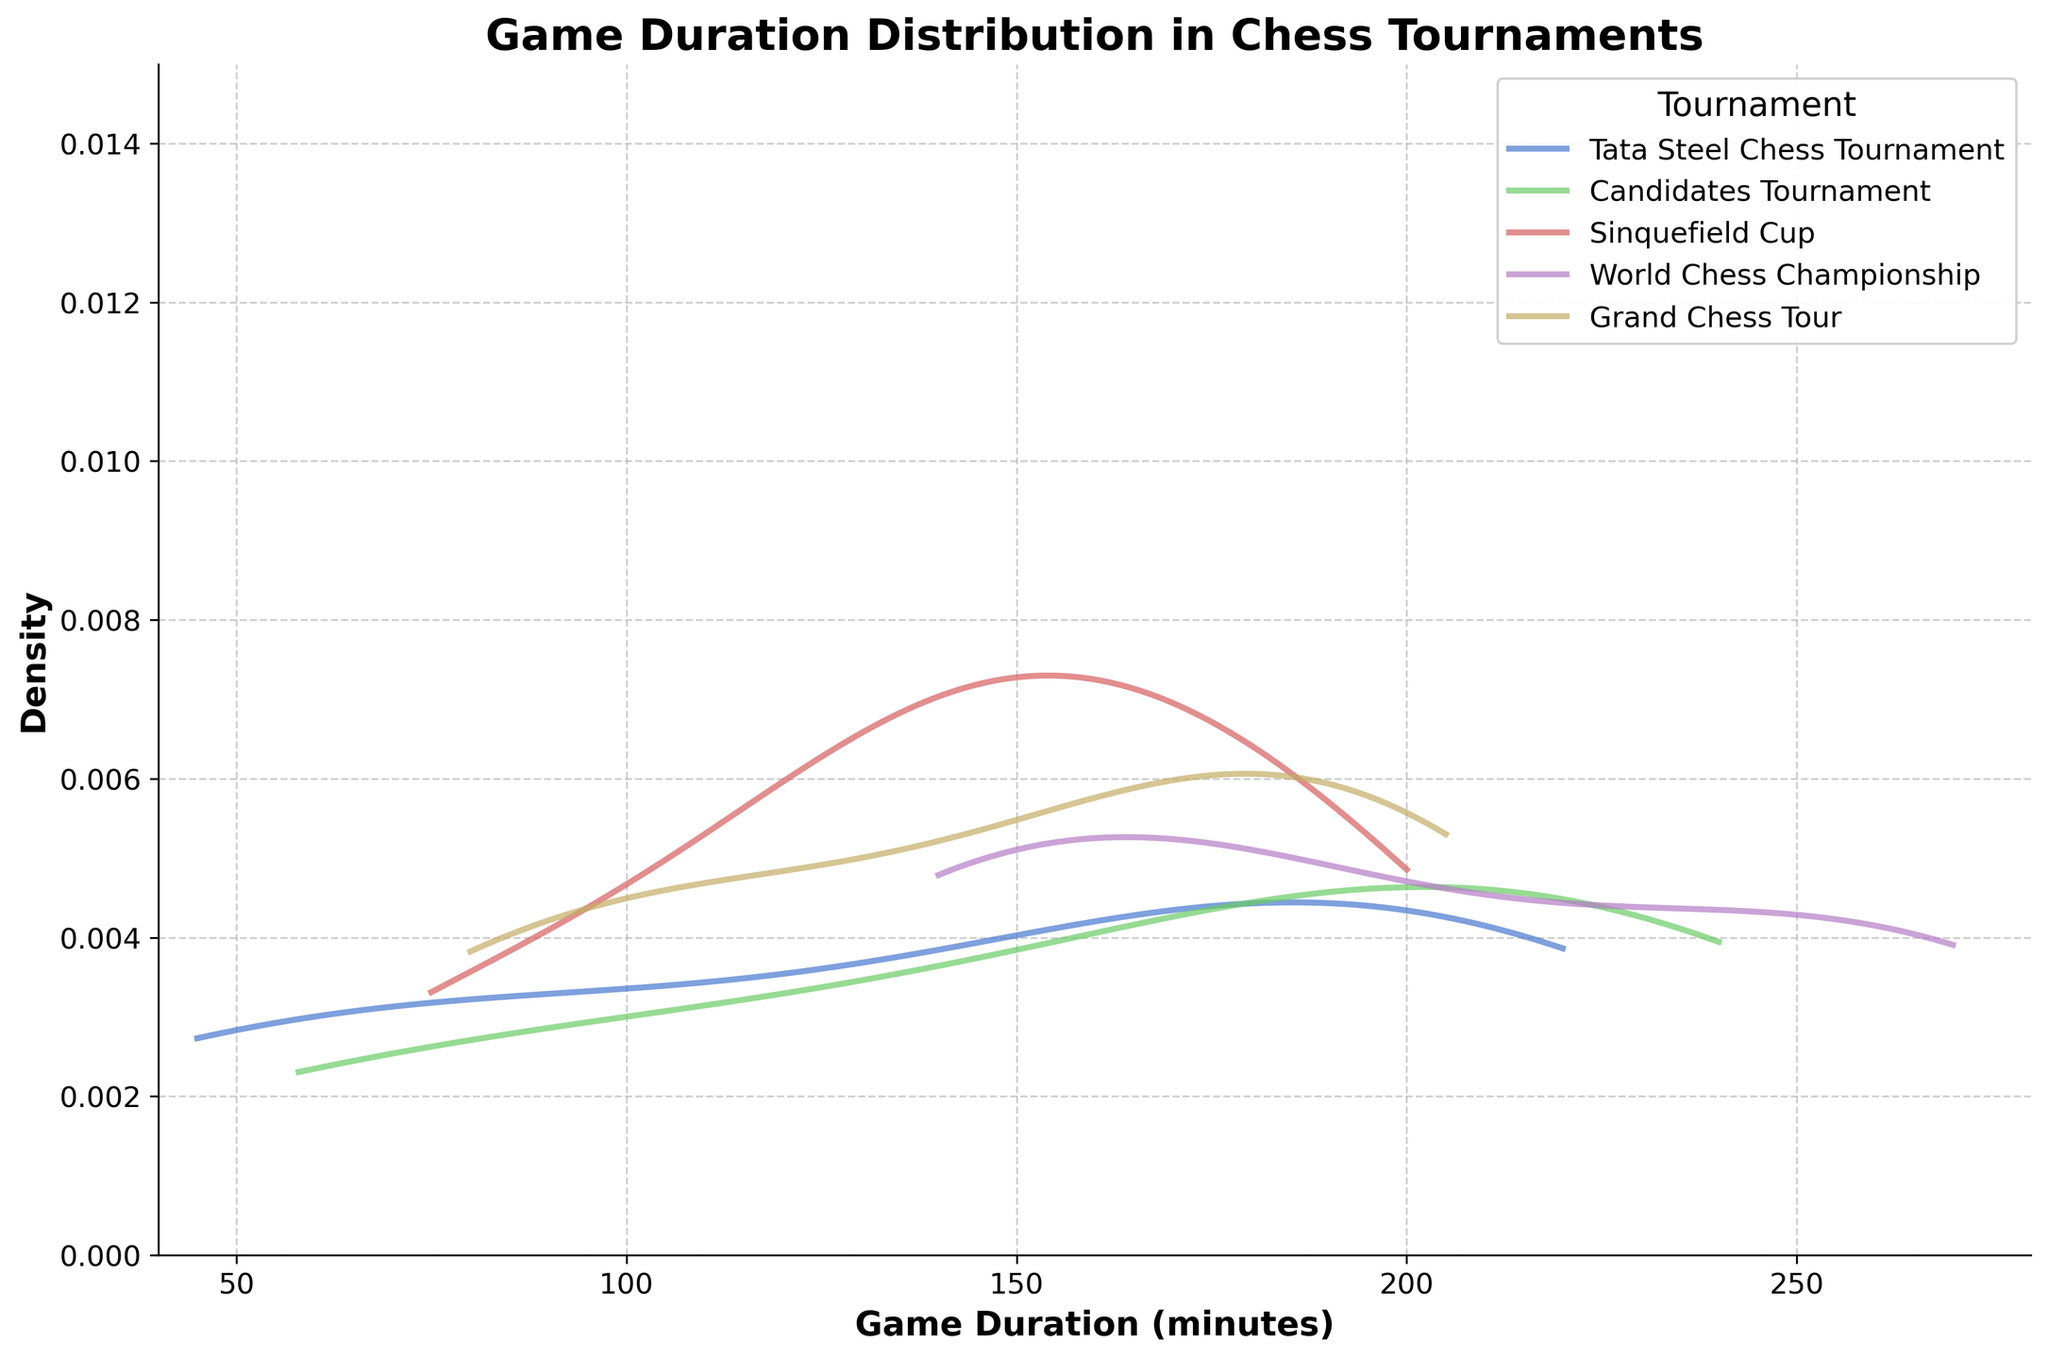What is the title of the figure? The title of the figure is located at the top center of the plot and is typically larger in font size compared to other text elements. It summarizes the main subject of the plot.
Answer: Game Duration Distribution in Chess Tournaments How many different tournaments are represented in the plot? The plot legend lists all the tournaments represented in the figure. Each distinct label corresponds to a different tournament.
Answer: Five Which tournament has the broadest range of game durations? By examining the width of the density curves, we can determine which tournament has the widest distribution of game durations. The broadest curve spans the largest range on the x-axis.
Answer: World Chess Championship Which tournament has a peak density closest to game durations of around 80-100 minutes? We need to check which tournament's density curve peaks (has the highest value) around the interval of 80-100 minutes on the x-axis.
Answer: Tata Steel Chess Tournament What is the maximum game duration observed in the Sinquefield Cup? We look at the end of the density curve for the Sinquefield Cup on the x-axis to see the maximum value it reaches.
Answer: 200 minutes Which tournaments have game durations peaking above 200 minutes? The peaks of the density curves that are located beyond 200 minutes on the x-axis indicate such tournaments. We need to identify these curves.
Answer: Candidates Tournament, World Chess Championship How do the game duration densities of the Tata Steel Chess Tournament and the Candidates Tournament compare? We need to compare the shape and spread of the density curves for these two tournaments. Look at their respective peaks and the widths of the curves.
Answer: Tata Steel has a peak at shorter durations, while Candidates has a peak at longer durations and a wider spread What is a notable feature of the game duration distribution for the Grand Chess Tour? Focus on identifying any unique characteristics of the Grand Chess Tour's density curve, such as its peak, spread, or relative position on the x-axis.
Answer: Peaks around 205 minutes Which tournament has the most concentrated game duration distribution? The most concentrated distribution will have the highest peak and narrowest spread on the density curve.
Answer: Sinquefield Cup What is the common range of game durations for the Candidates Tournament? The common range can be inferred where the density is significant (not close to zero). Check the intervals where the Candidates Tournament's density curve maintains noticeable height.
Answer: 58 to 240 minutes 